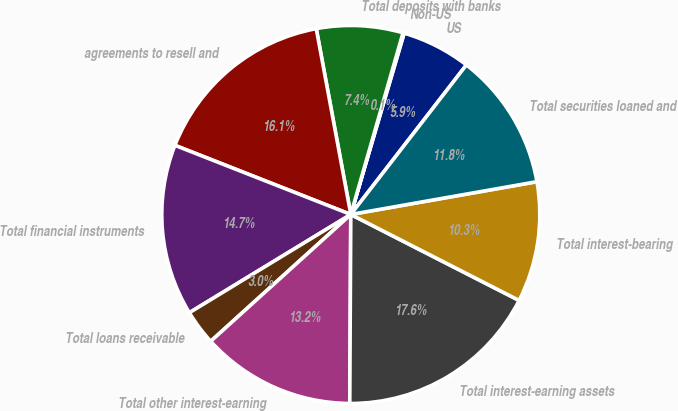Convert chart to OTSL. <chart><loc_0><loc_0><loc_500><loc_500><pie_chart><fcel>US<fcel>Non-US<fcel>Total deposits with banks<fcel>agreements to resell and<fcel>Total financial instruments<fcel>Total loans receivable<fcel>Total other interest-earning<fcel>Total interest-earning assets<fcel>Total interest-bearing<fcel>Total securities loaned and<nl><fcel>5.92%<fcel>0.1%<fcel>7.38%<fcel>16.11%<fcel>14.66%<fcel>3.01%<fcel>13.2%<fcel>17.57%<fcel>10.29%<fcel>11.75%<nl></chart> 